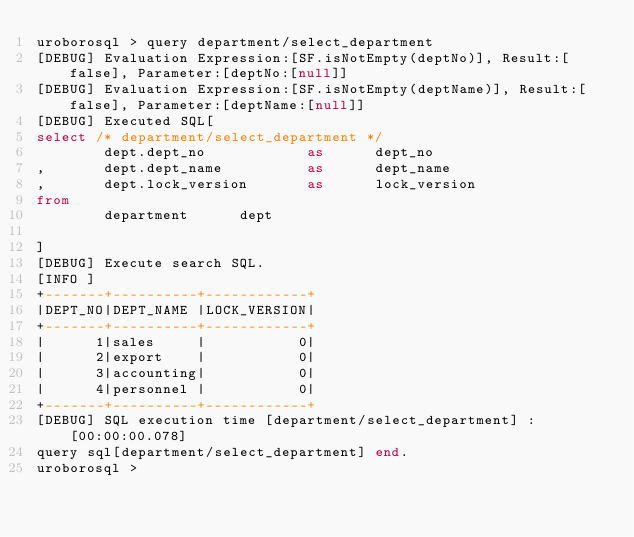<code> <loc_0><loc_0><loc_500><loc_500><_SQL_>uroborosql > query department/select_department
[DEBUG] Evaluation Expression:[SF.isNotEmpty(deptNo)], Result:[false], Parameter:[deptNo:[null]]
[DEBUG] Evaluation Expression:[SF.isNotEmpty(deptName)], Result:[false], Parameter:[deptName:[null]]
[DEBUG] Executed SQL[
select /* department/select_department */
        dept.dept_no            as      dept_no
,       dept.dept_name          as      dept_name
,       dept.lock_version       as      lock_version
from
        department      dept

]
[DEBUG] Execute search SQL.
[INFO ]
+-------+----------+------------+
|DEPT_NO|DEPT_NAME |LOCK_VERSION|
+-------+----------+------------+
|      1|sales     |           0|
|      2|export    |           0|
|      3|accounting|           0|
|      4|personnel |           0|
+-------+----------+------------+
[DEBUG] SQL execution time [department/select_department] : [00:00:00.078]
query sql[department/select_department] end.
uroborosql ></code> 